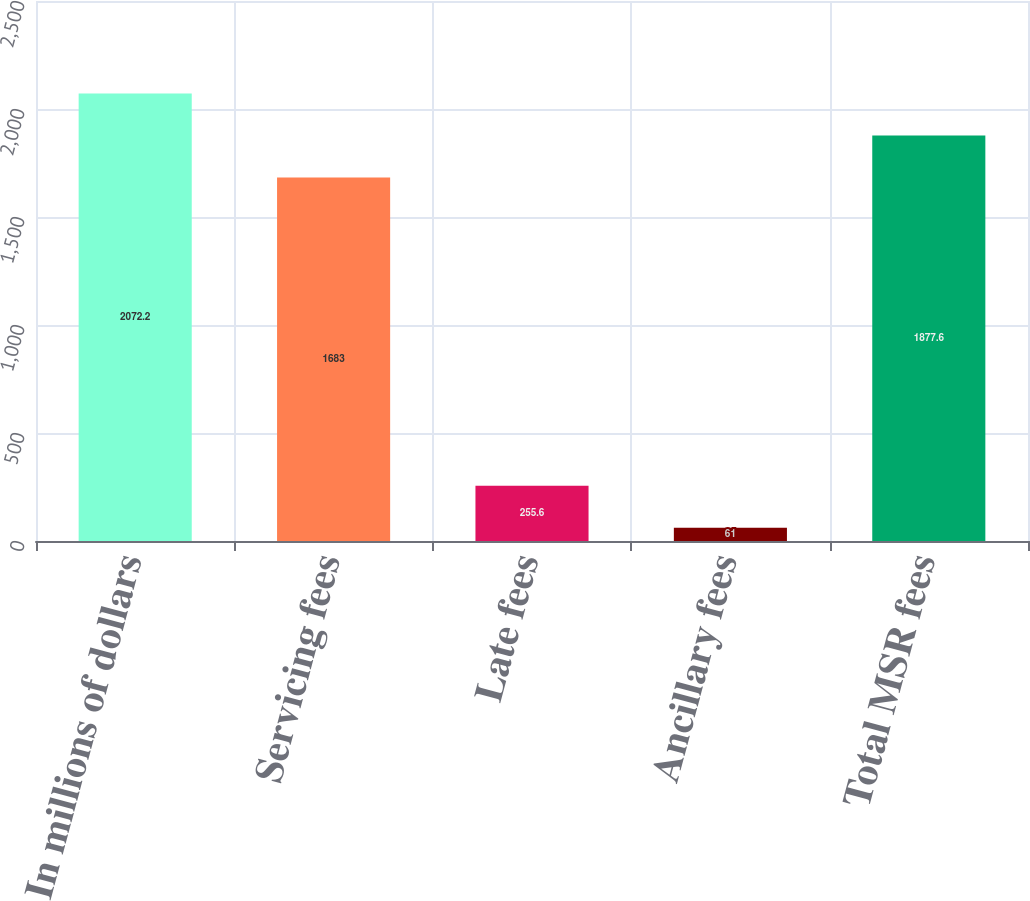Convert chart. <chart><loc_0><loc_0><loc_500><loc_500><bar_chart><fcel>In millions of dollars<fcel>Servicing fees<fcel>Late fees<fcel>Ancillary fees<fcel>Total MSR fees<nl><fcel>2072.2<fcel>1683<fcel>255.6<fcel>61<fcel>1877.6<nl></chart> 